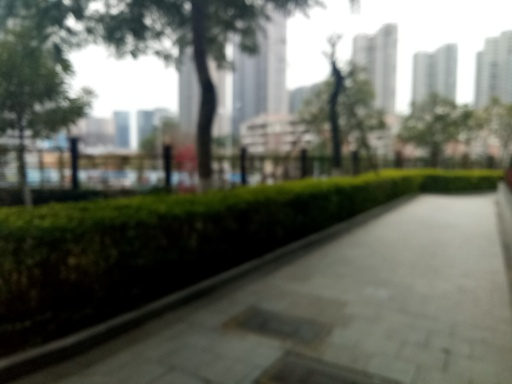Can you tell me something about the location or setting of this image? This image appears to show a pedestrian walkway in an urban park. The park is likely located within a city given the visible high-rise buildings in the background. The structured layout of the path and the manicured greenery suggest that it's a well-maintained public space. 